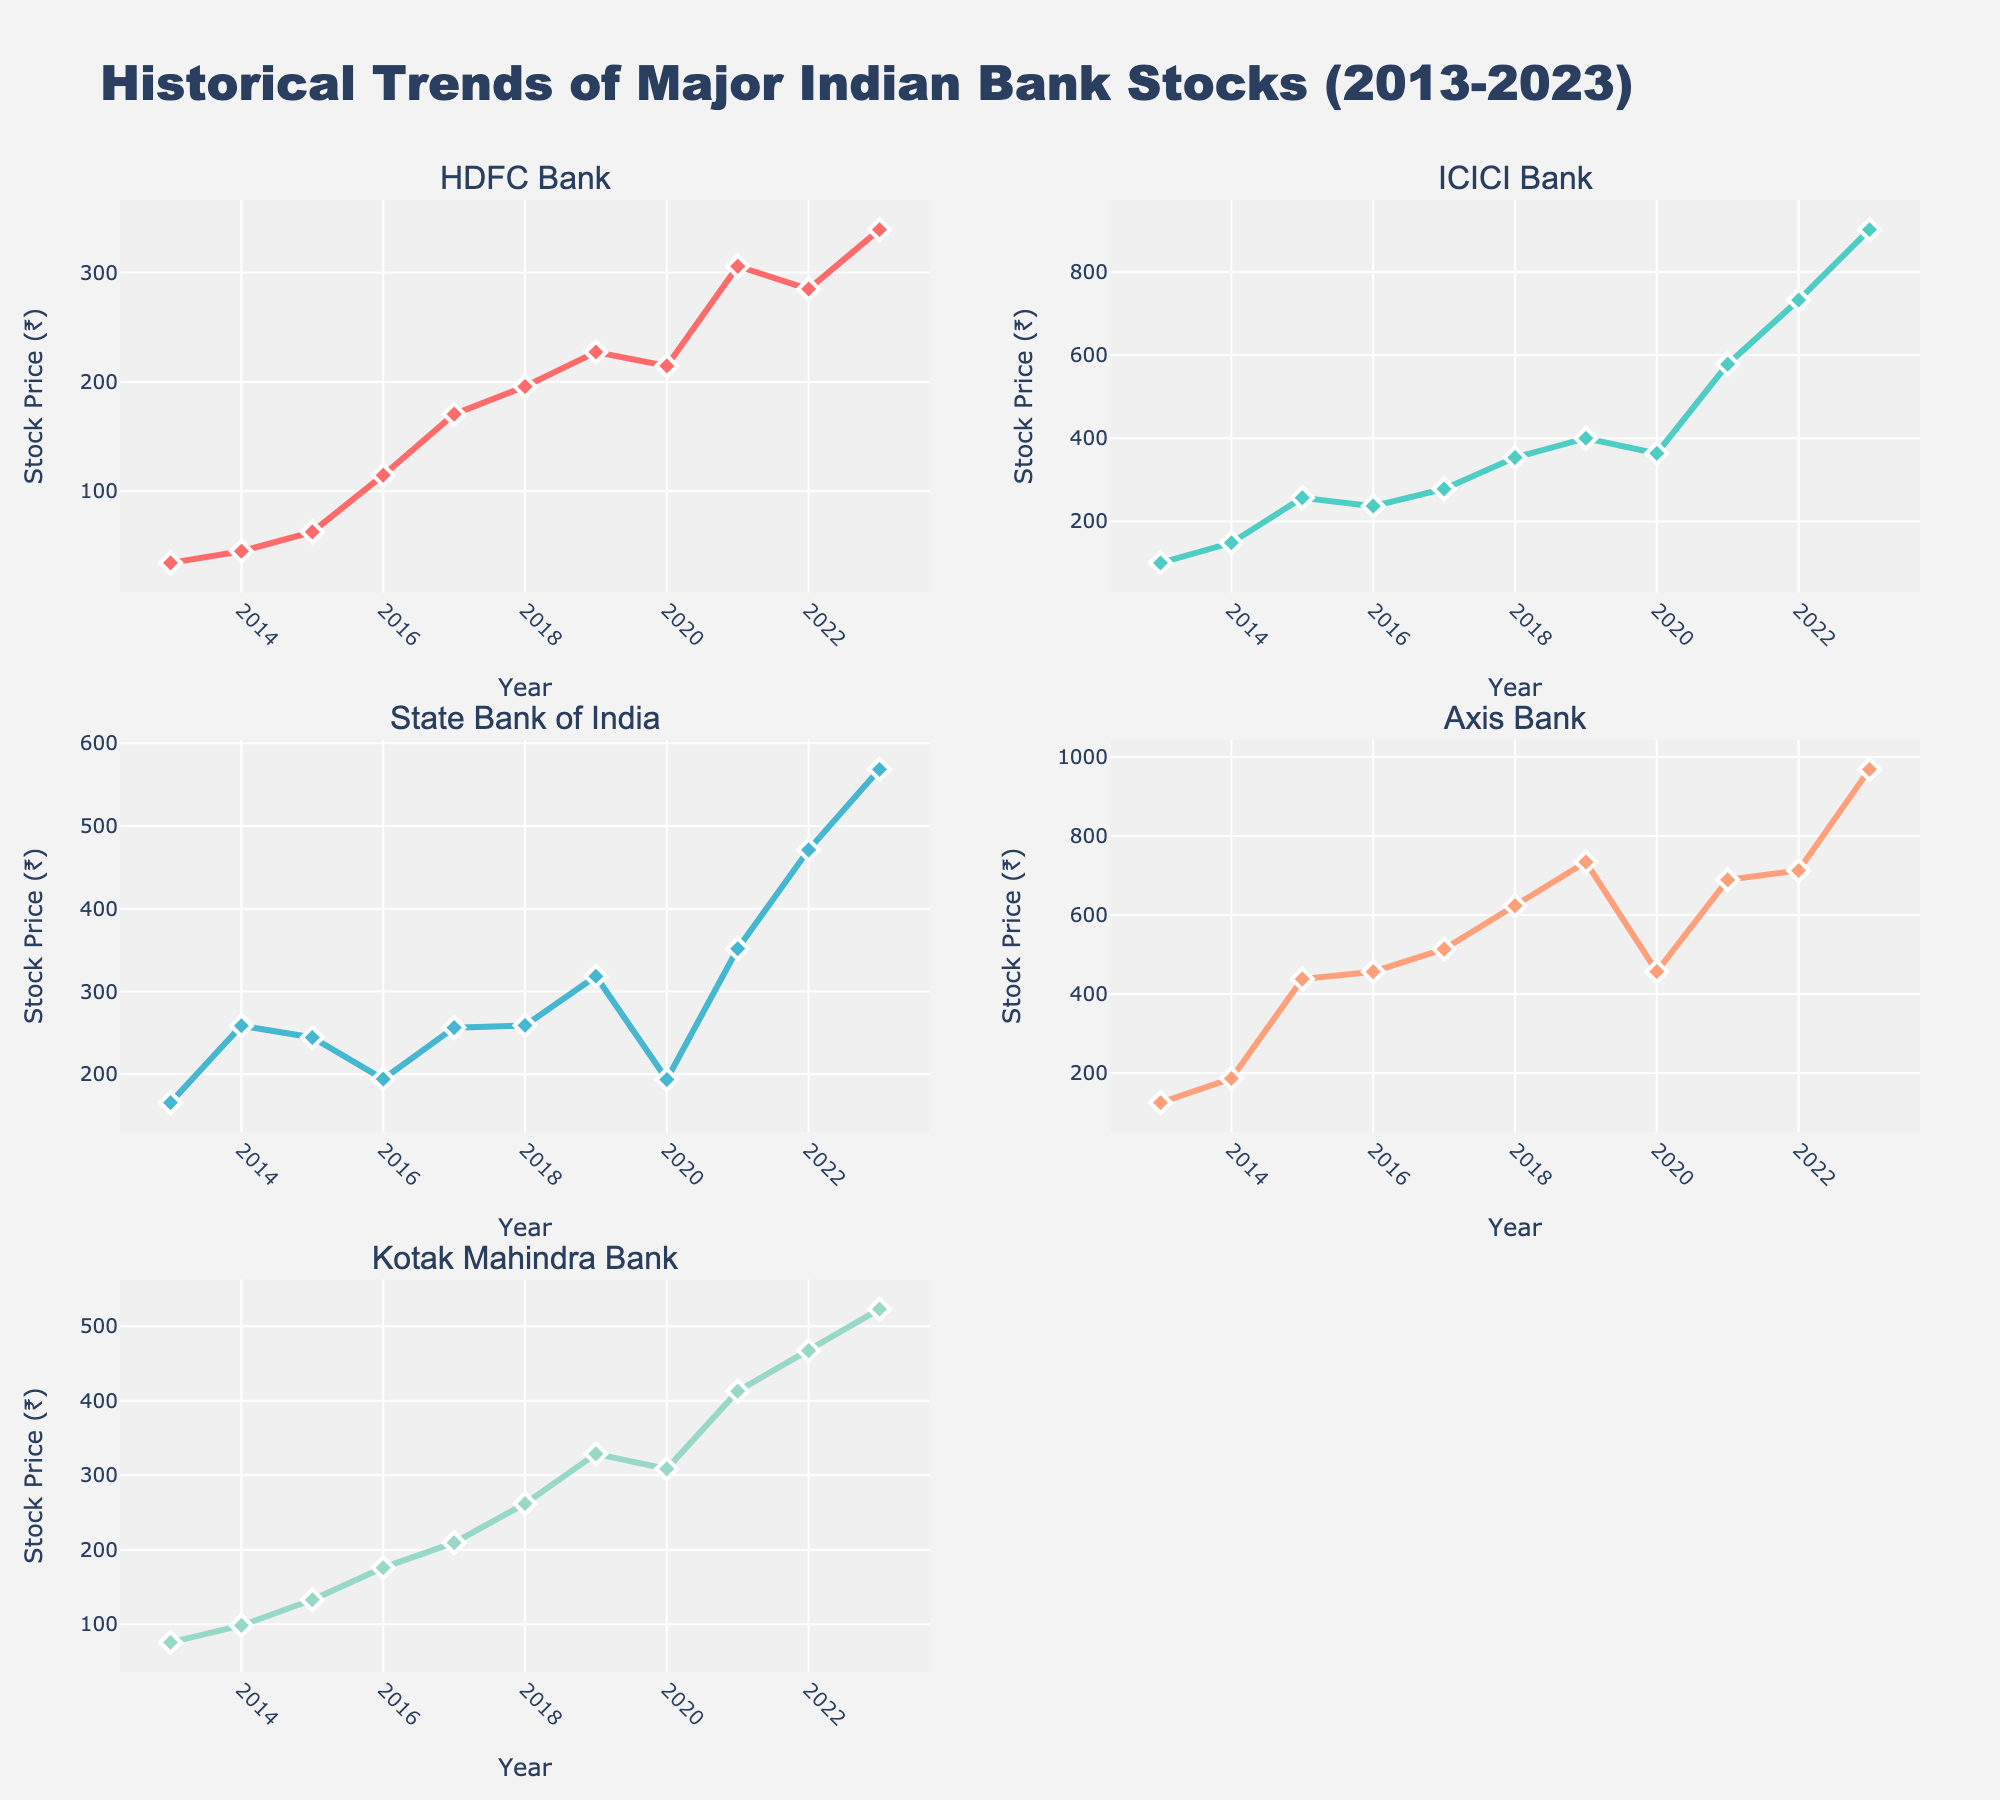Which Indian bank had the highest stock price in 2023? According to the top right subplot for Axis Bank, in 2023 Axis Bank's stock price is higher than the other banks.
Answer: Axis Bank What was the stock price of HDFC Bank in 2013? The top-left subplot for HDFC Bank indicates the stock price for the year 2013.
Answer: 34.5 Which bank had the lowest stock price in 2016? By checking all subplots for the year 2016, HDFC Bank had the lowest stock price.
Answer: HDFC Bank How did the stock price of Kotak Mahindra Bank change from 2020 to 2021? In the bottom-left subplot for Kotak Mahindra Bank, the stock price increased from around 308.5 in 2020 to 412.7 in 2021.
Answer: Increased What was the average stock price of ICICI Bank over the first three years (2013-2015)? Sum the stock prices of ICICI Bank for 2013, 2014, and 2015, then divide by 3: (100.2 + 148.6 + 256.9) / 3 = 168.57.
Answer: 168.6 Did the stock price of State Bank of India ever decrease over the period shown? In the middle-left subplot for State Bank of India, the stock prices show a decrease between 2019 and 2020.
Answer: Yes What is the difference in stock price between 2022 and 2023 for ICICI Bank? The subplot for ICICI Bank shows the stock prices as 732.5 in 2022 and 901.8 in 2023. The difference is 901.8 - 732.5 = 169.3.
Answer: 169.3 Which bank experienced the most significant stock price increase between 2013 and 2023? By comparing the increase in stock prices from 2013 to 2023 across all subplots, Axis Bank increased from 125.3 to 968.7, the most significant increase.
Answer: Axis Bank What is the median stock price of HDFC Bank over the depicted years? To find the median, list the stock prices of HDFC Bank and find the middle value after sorting them: (34.5, 45.2, 62.8, 114.7, 170.5, 195.8, 227.3, 214.6, 305.7, 284.9, 339.2). The median value is 195.8.
Answer: 195.8 